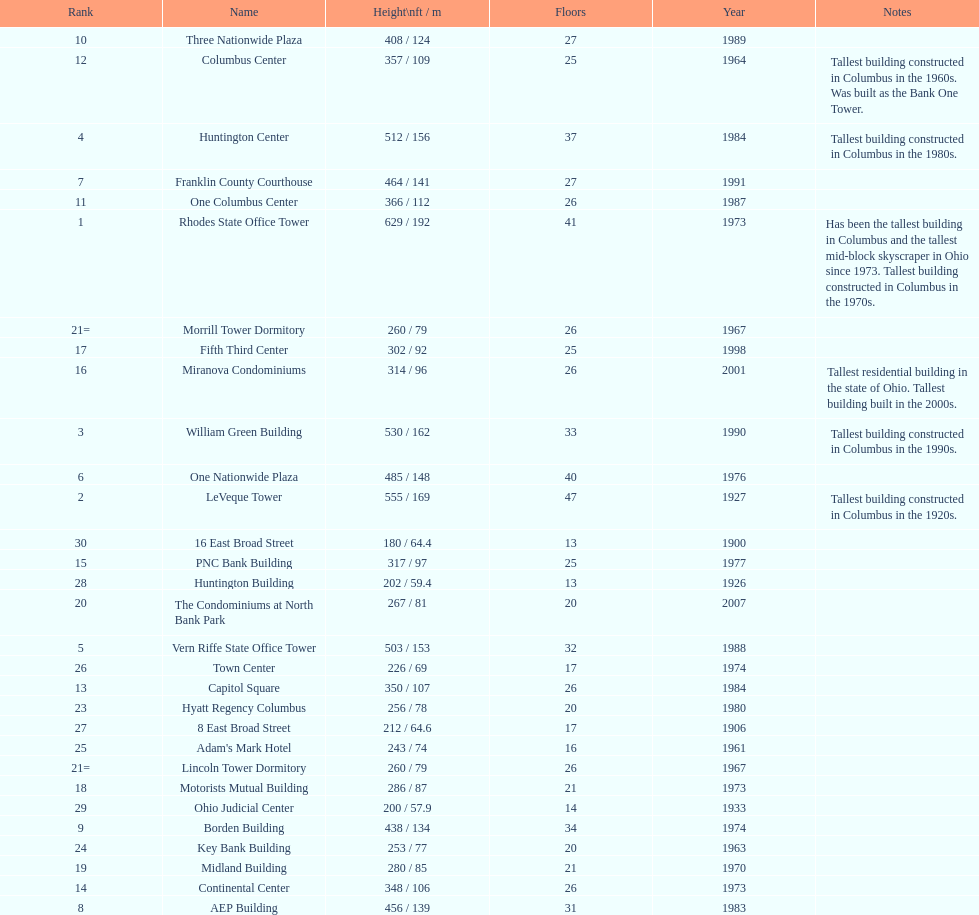Which is the tallest building? Rhodes State Office Tower. Can you give me this table as a dict? {'header': ['Rank', 'Name', 'Height\\nft / m', 'Floors', 'Year', 'Notes'], 'rows': [['10', 'Three Nationwide Plaza', '408 / 124', '27', '1989', ''], ['12', 'Columbus Center', '357 / 109', '25', '1964', 'Tallest building constructed in Columbus in the 1960s. Was built as the Bank One Tower.'], ['4', 'Huntington Center', '512 / 156', '37', '1984', 'Tallest building constructed in Columbus in the 1980s.'], ['7', 'Franklin County Courthouse', '464 / 141', '27', '1991', ''], ['11', 'One Columbus Center', '366 / 112', '26', '1987', ''], ['1', 'Rhodes State Office Tower', '629 / 192', '41', '1973', 'Has been the tallest building in Columbus and the tallest mid-block skyscraper in Ohio since 1973. Tallest building constructed in Columbus in the 1970s.'], ['21=', 'Morrill Tower Dormitory', '260 / 79', '26', '1967', ''], ['17', 'Fifth Third Center', '302 / 92', '25', '1998', ''], ['16', 'Miranova Condominiums', '314 / 96', '26', '2001', 'Tallest residential building in the state of Ohio. Tallest building built in the 2000s.'], ['3', 'William Green Building', '530 / 162', '33', '1990', 'Tallest building constructed in Columbus in the 1990s.'], ['6', 'One Nationwide Plaza', '485 / 148', '40', '1976', ''], ['2', 'LeVeque Tower', '555 / 169', '47', '1927', 'Tallest building constructed in Columbus in the 1920s.'], ['30', '16 East Broad Street', '180 / 64.4', '13', '1900', ''], ['15', 'PNC Bank Building', '317 / 97', '25', '1977', ''], ['28', 'Huntington Building', '202 / 59.4', '13', '1926', ''], ['20', 'The Condominiums at North Bank Park', '267 / 81', '20', '2007', ''], ['5', 'Vern Riffe State Office Tower', '503 / 153', '32', '1988', ''], ['26', 'Town Center', '226 / 69', '17', '1974', ''], ['13', 'Capitol Square', '350 / 107', '26', '1984', ''], ['23', 'Hyatt Regency Columbus', '256 / 78', '20', '1980', ''], ['27', '8 East Broad Street', '212 / 64.6', '17', '1906', ''], ['25', "Adam's Mark Hotel", '243 / 74', '16', '1961', ''], ['21=', 'Lincoln Tower Dormitory', '260 / 79', '26', '1967', ''], ['18', 'Motorists Mutual Building', '286 / 87', '21', '1973', ''], ['29', 'Ohio Judicial Center', '200 / 57.9', '14', '1933', ''], ['9', 'Borden Building', '438 / 134', '34', '1974', ''], ['24', 'Key Bank Building', '253 / 77', '20', '1963', ''], ['19', 'Midland Building', '280 / 85', '21', '1970', ''], ['14', 'Continental Center', '348 / 106', '26', '1973', ''], ['8', 'AEP Building', '456 / 139', '31', '1983', '']]} 